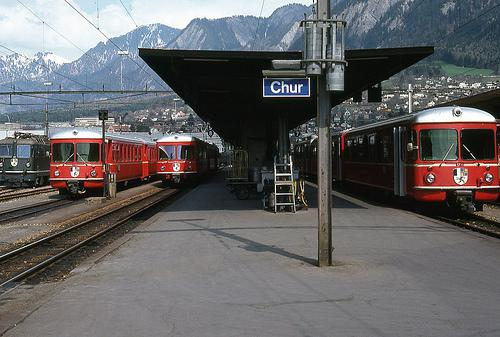Question: how many trains are there?
Choices:
A. 3.
B. 4.
C. 2.
D. 5.
Answer with the letter. Answer: B Question: what is the color of many trains?
Choices:
A. Black.
B. Red.
C. Silver.
D. Grey.
Answer with the letter. Answer: B Question: where was the picture taken from?
Choices:
A. Station.
B. Platform.
C. Street.
D. Office.
Answer with the letter. Answer: A Question: what is behind the station?
Choices:
A. Buildings.
B. Woods.
C. Mountain.
D. Roads.
Answer with the letter. Answer: C Question: what is written on the board?
Choices:
A. Next.
B. Upcoming.
C. Soon.
D. Chur.
Answer with the letter. Answer: D Question: who is driving them?
Choices:
A. The man.
B. The woman.
C. The driver.
D. The employee.
Answer with the letter. Answer: C 